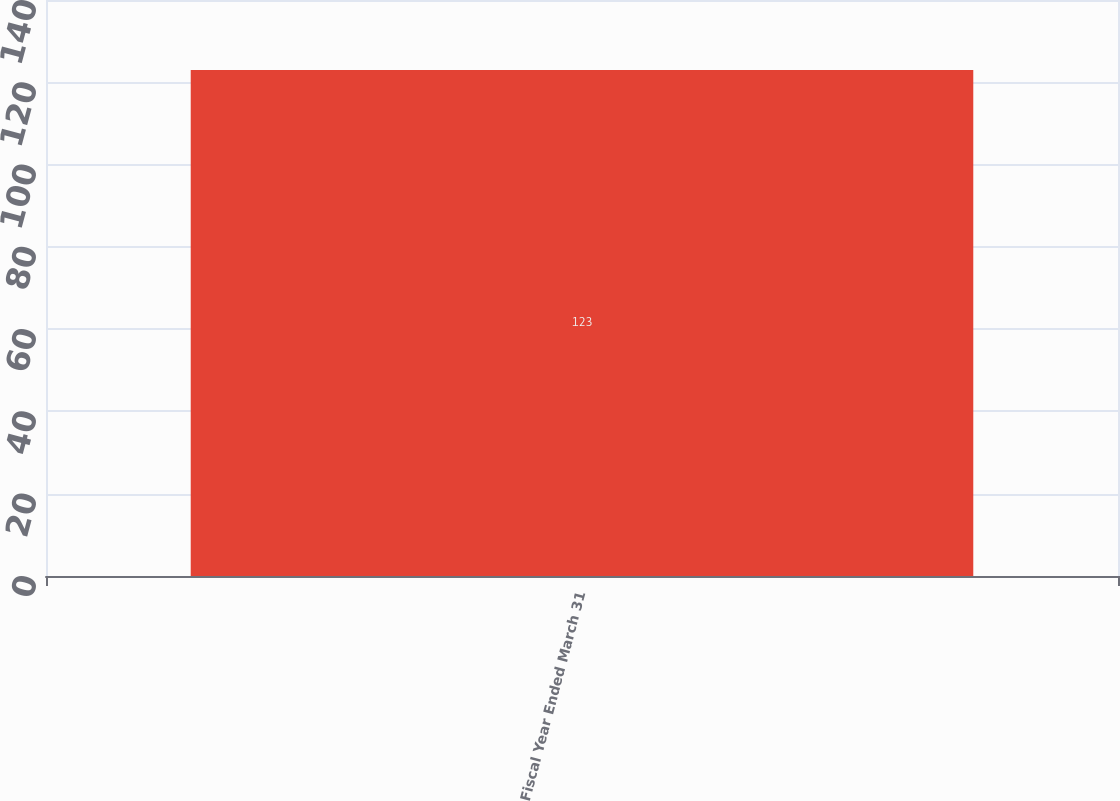Convert chart to OTSL. <chart><loc_0><loc_0><loc_500><loc_500><bar_chart><fcel>Fiscal Year Ended March 31<nl><fcel>123<nl></chart> 